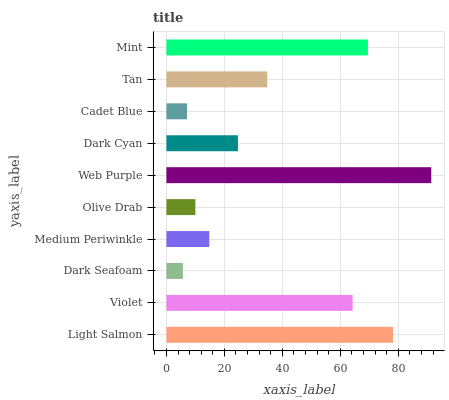Is Dark Seafoam the minimum?
Answer yes or no. Yes. Is Web Purple the maximum?
Answer yes or no. Yes. Is Violet the minimum?
Answer yes or no. No. Is Violet the maximum?
Answer yes or no. No. Is Light Salmon greater than Violet?
Answer yes or no. Yes. Is Violet less than Light Salmon?
Answer yes or no. Yes. Is Violet greater than Light Salmon?
Answer yes or no. No. Is Light Salmon less than Violet?
Answer yes or no. No. Is Tan the high median?
Answer yes or no. Yes. Is Dark Cyan the low median?
Answer yes or no. Yes. Is Dark Seafoam the high median?
Answer yes or no. No. Is Web Purple the low median?
Answer yes or no. No. 